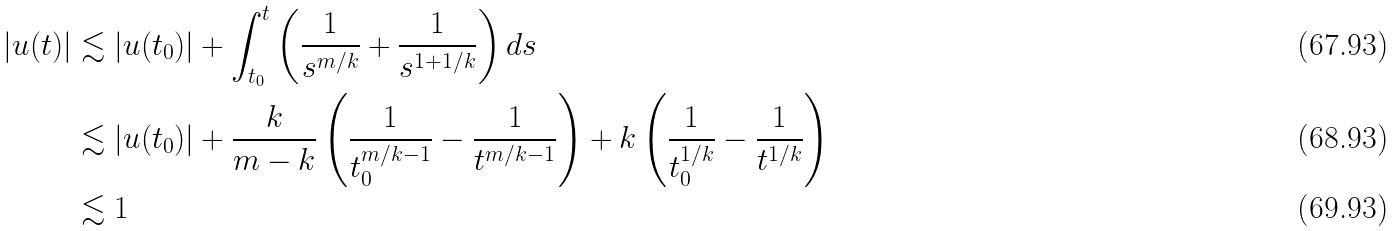Convert formula to latex. <formula><loc_0><loc_0><loc_500><loc_500>| u ( t ) | & \lesssim | u ( t _ { 0 } ) | + \int _ { t _ { 0 } } ^ { t } \left ( \frac { 1 } { s ^ { m / k } } + \frac { 1 } { s ^ { 1 + 1 / k } } \right ) d s \\ & \lesssim | u ( t _ { 0 } ) | + \frac { k } { m - k } \left ( \frac { 1 } { t _ { 0 } ^ { m / k - 1 } } - \frac { 1 } { t ^ { m / k - 1 } } \right ) + k \left ( \frac { 1 } { t _ { 0 } ^ { 1 / k } } - \frac { 1 } { t ^ { 1 / k } } \right ) \\ & \lesssim 1</formula> 